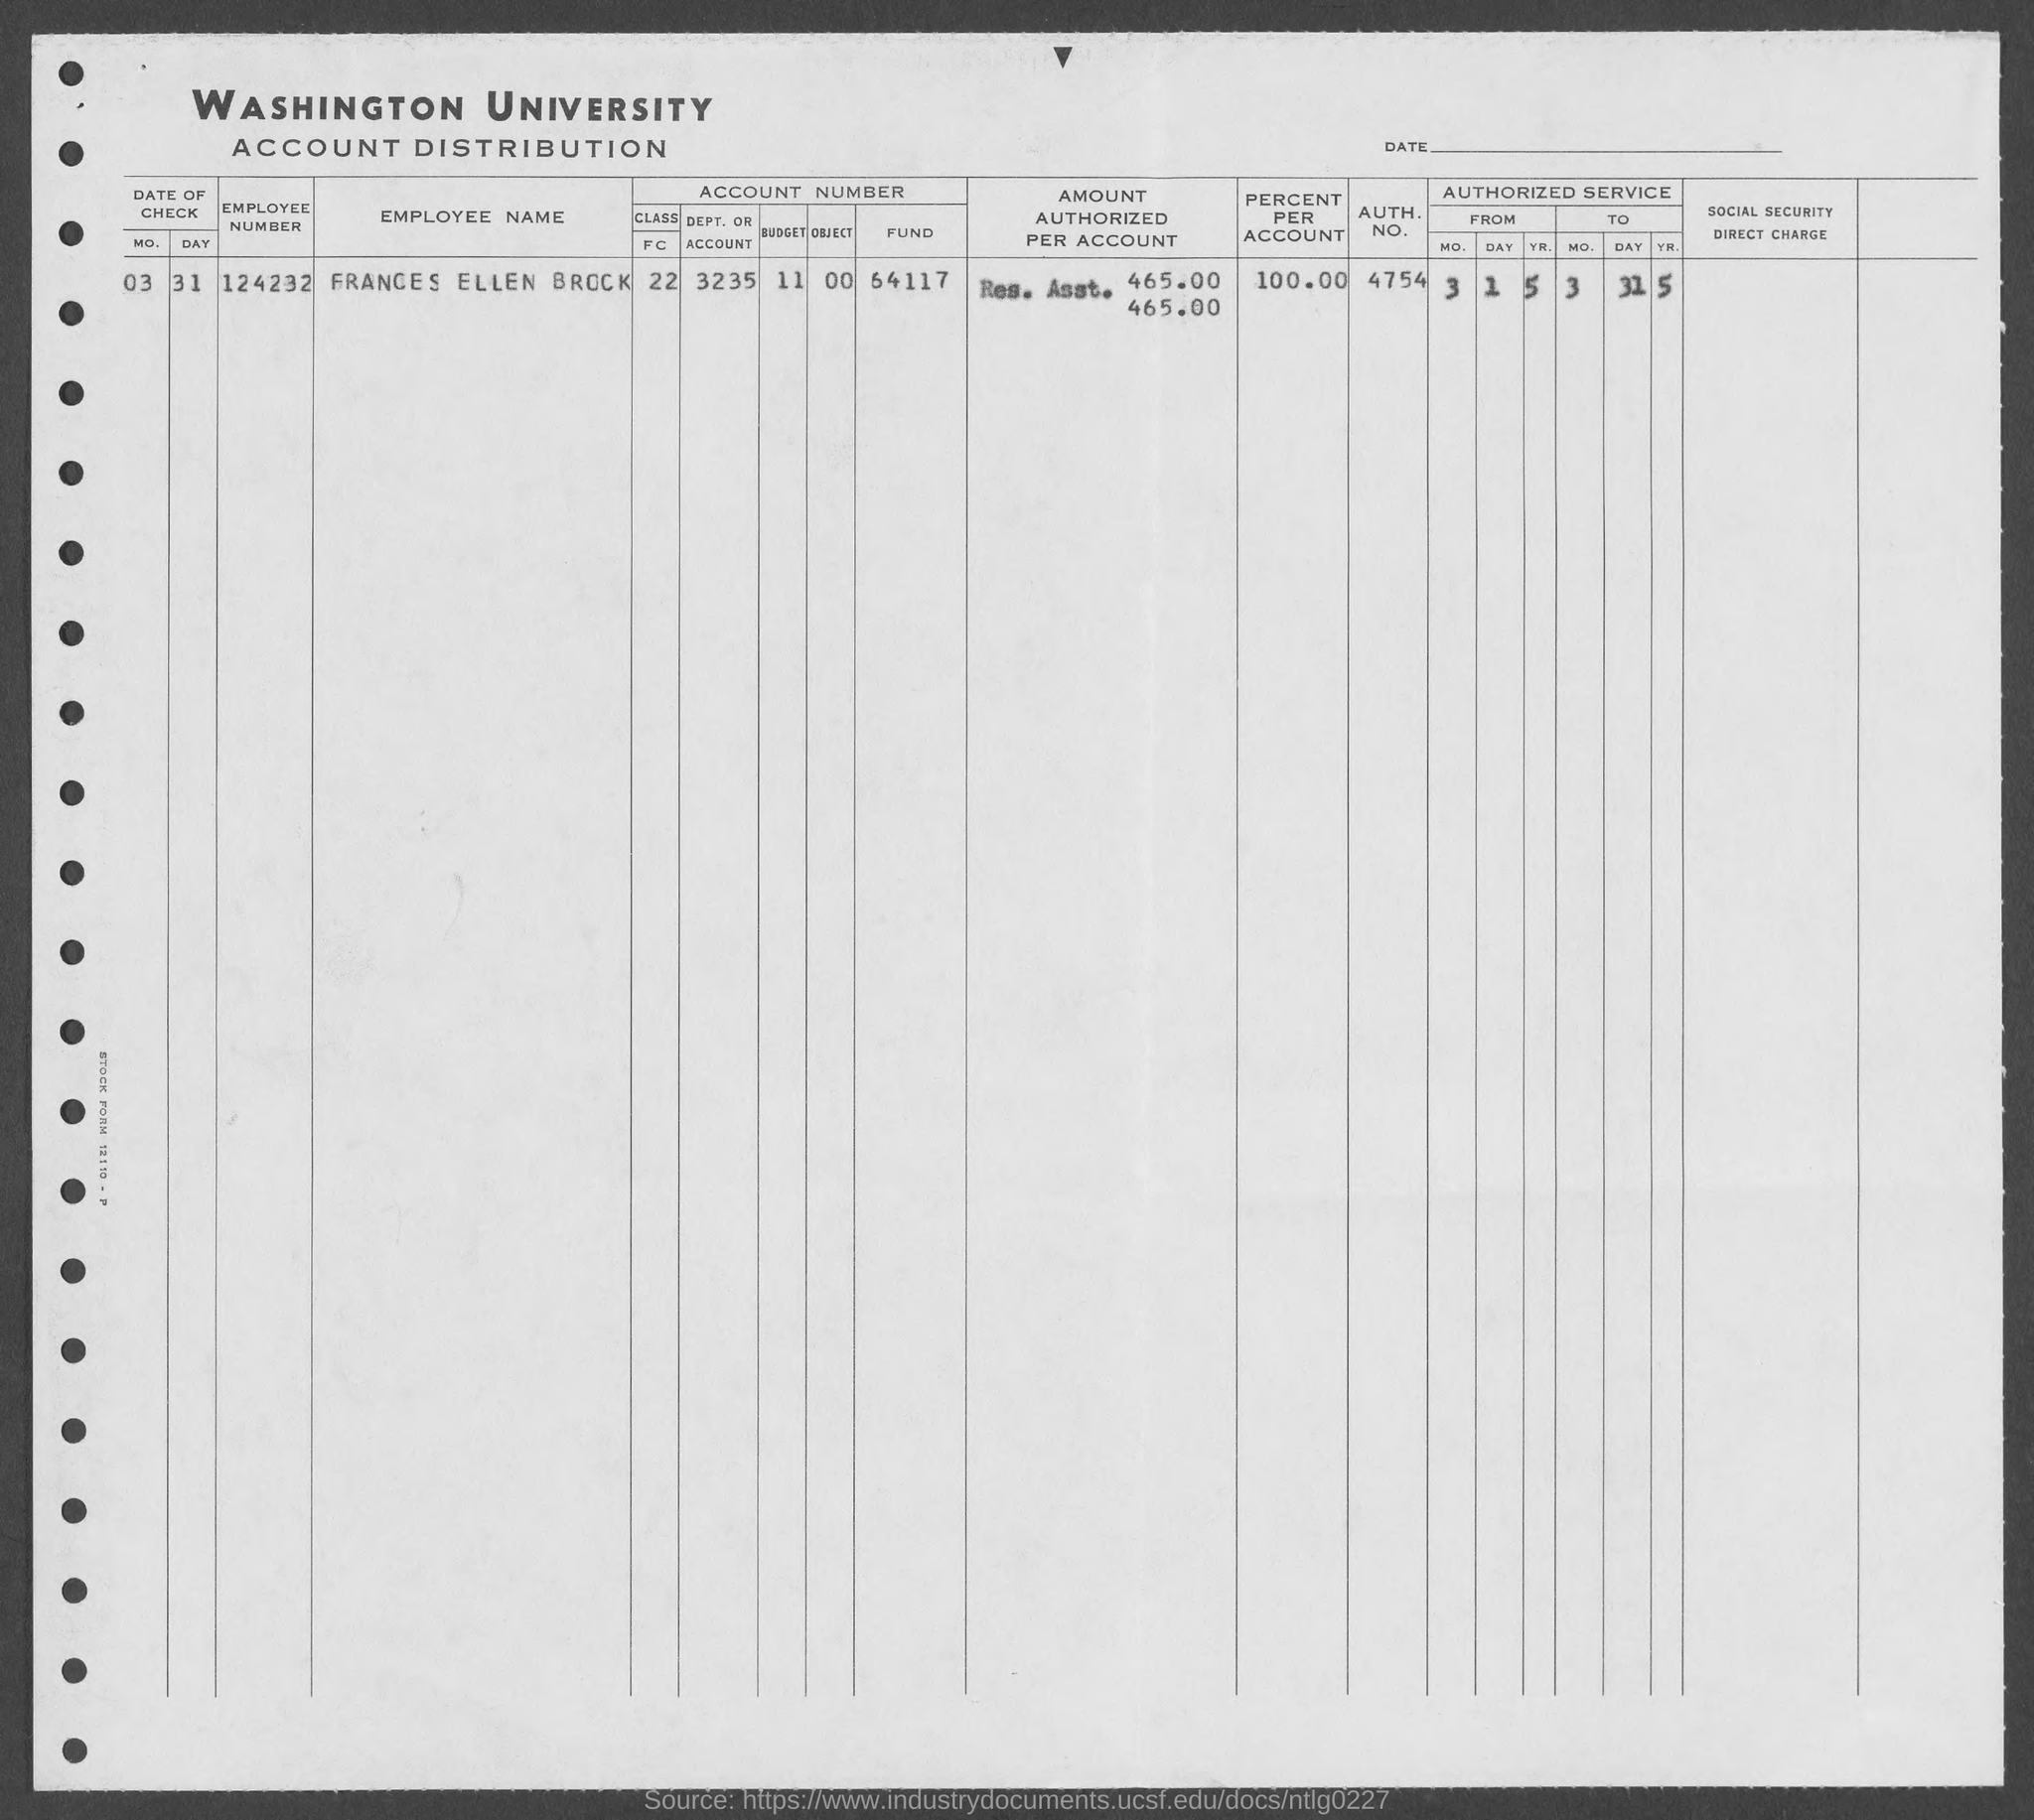Point out several critical features in this image. The employee number of Frances Ellen Brock is 124232. What is the authentication number of Frances Ellen Brock? It is 4754. 